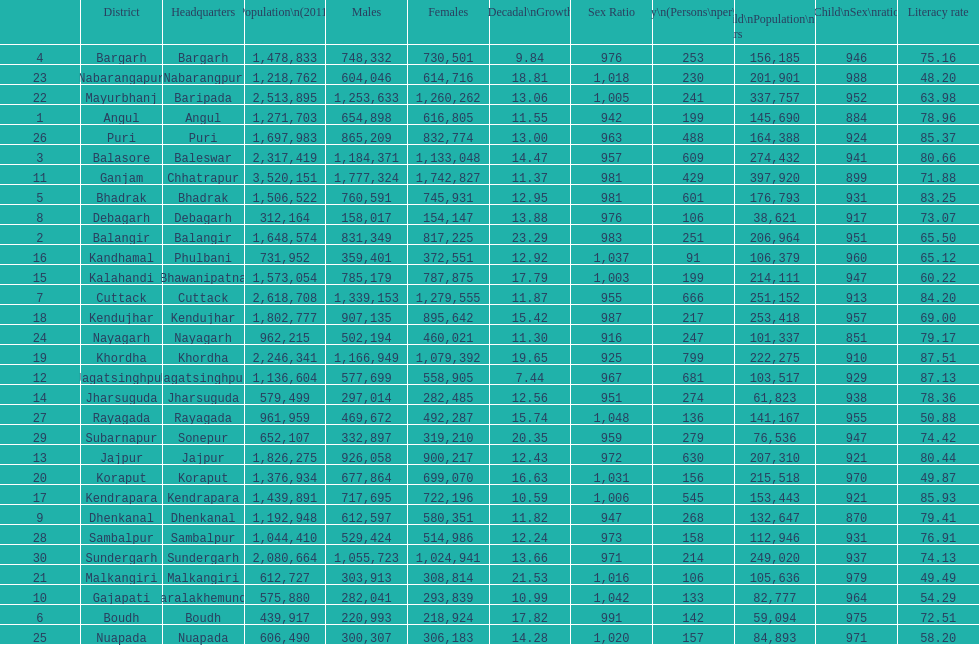Which city has the lowest literacy level? Nabarangapur. 